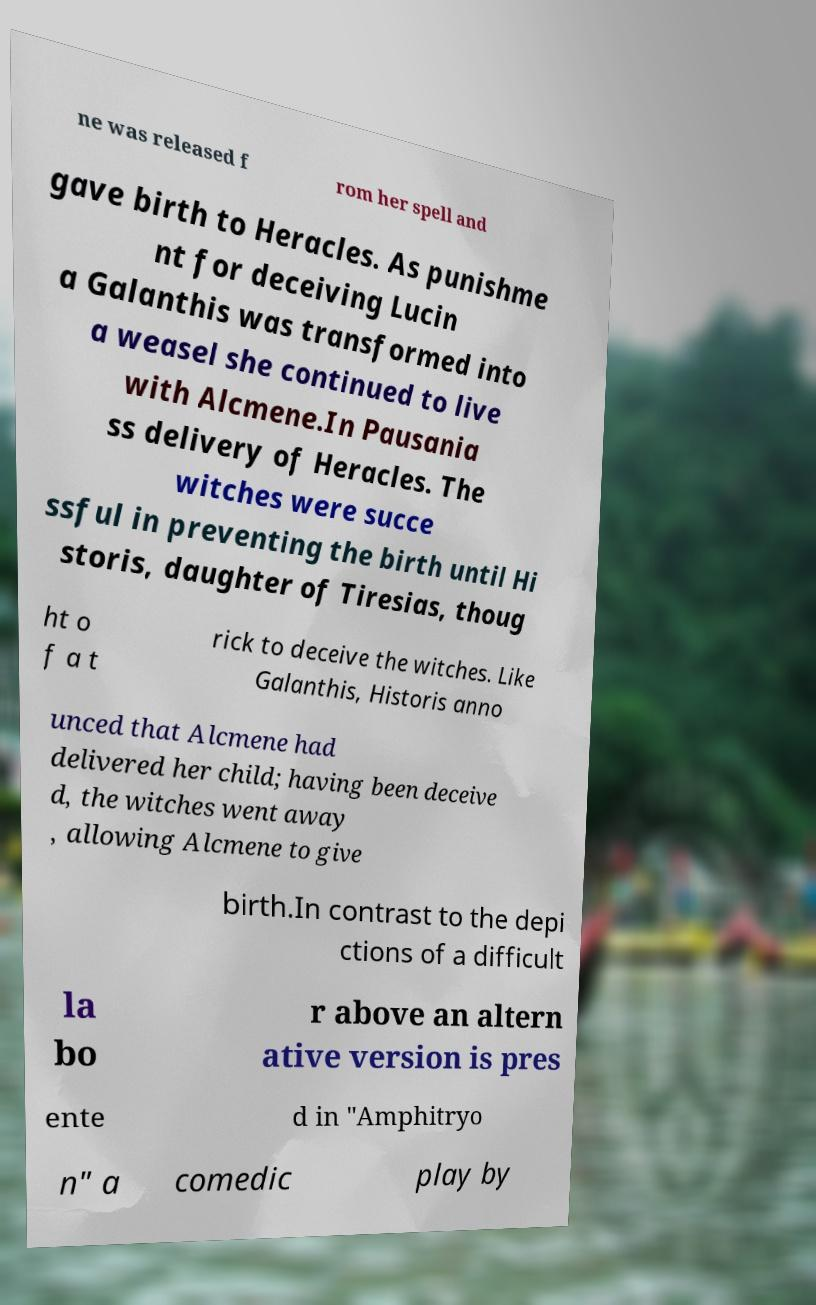Could you assist in decoding the text presented in this image and type it out clearly? ne was released f rom her spell and gave birth to Heracles. As punishme nt for deceiving Lucin a Galanthis was transformed into a weasel she continued to live with Alcmene.In Pausania ss delivery of Heracles. The witches were succe ssful in preventing the birth until Hi storis, daughter of Tiresias, thoug ht o f a t rick to deceive the witches. Like Galanthis, Historis anno unced that Alcmene had delivered her child; having been deceive d, the witches went away , allowing Alcmene to give birth.In contrast to the depi ctions of a difficult la bo r above an altern ative version is pres ente d in "Amphitryo n" a comedic play by 